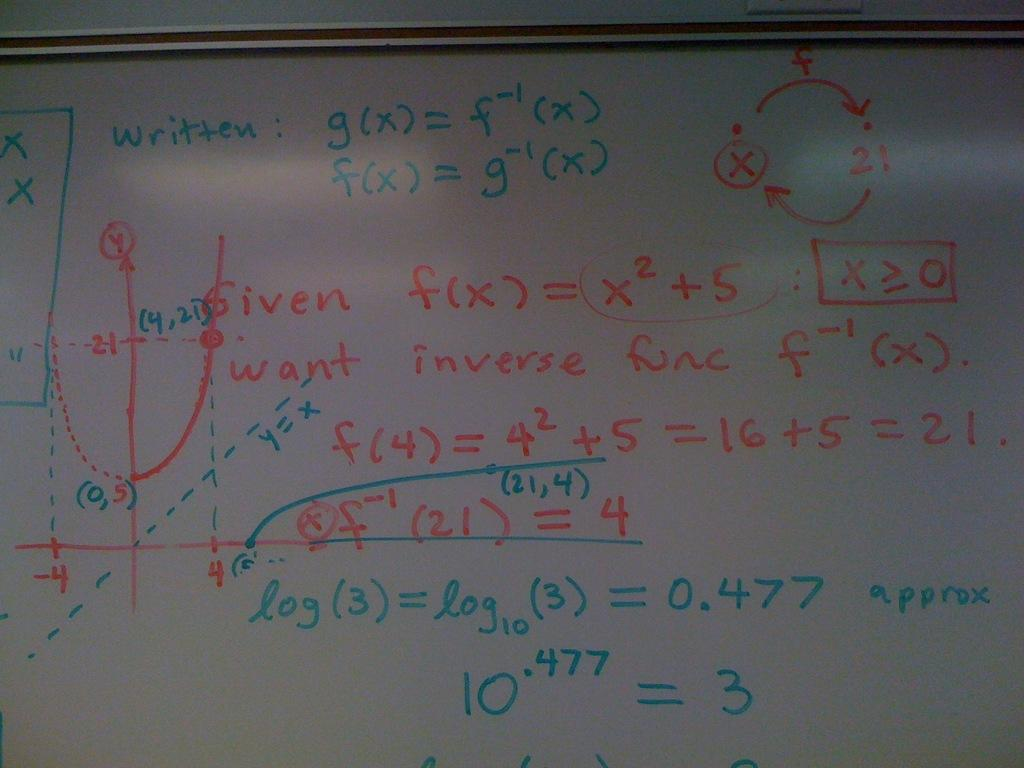Provide a one-sentence caption for the provided image. given f(x) = x2 + 5 is written on a board of math equations. 